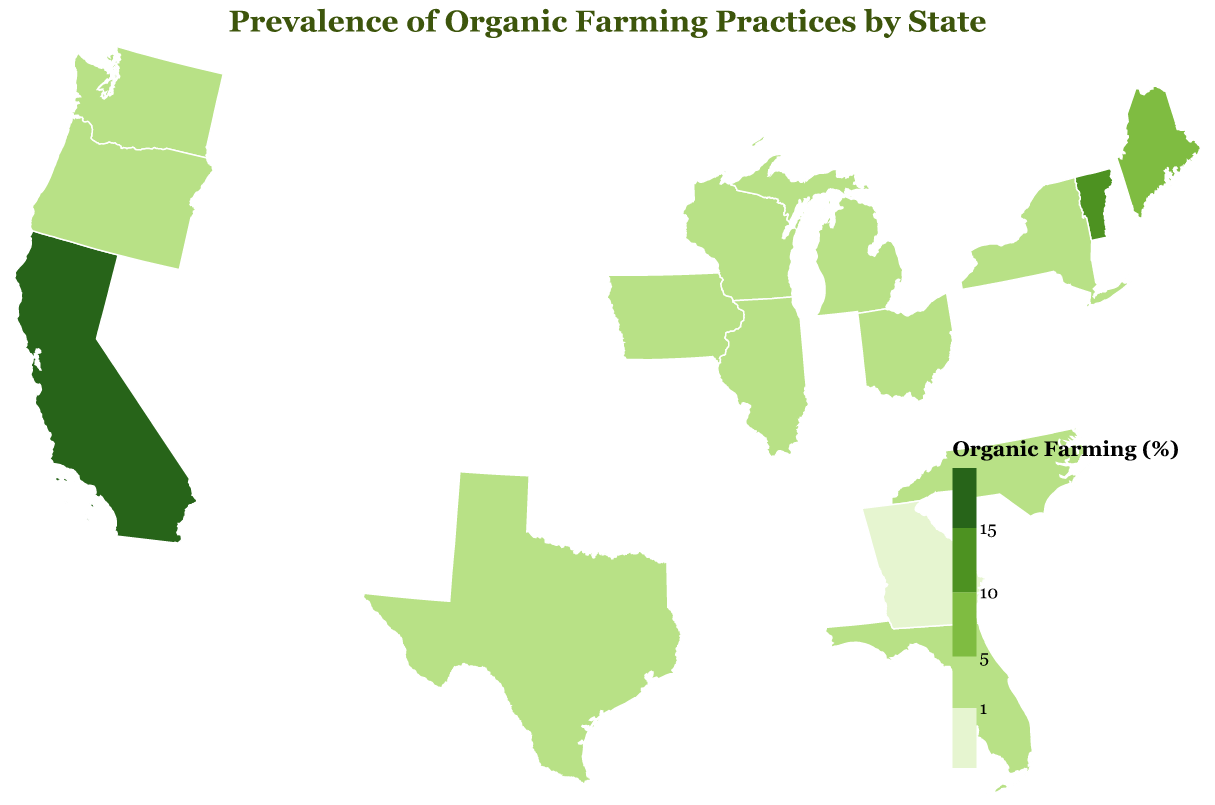What is the title of the figure? The title of a figure is usually displayed at the top and summarizes the main point of the visual data. Here, it is clearly stated at the top.
Answer: Prevalence of Organic Farming Practices by State Which state has the highest percentage of organic farming practices? By looking for the state with the highest value on the map or legend with the darkest color, you can identify the state with the highest percentage.
Answer: California What is the percentage of organic farming in Vermont? Hover over Vermont on the map or find it in the legend to see the exact percentage marked.
Answer: 14.8% Are there any states where the percentage of organic farming practices is below 1%? Looking at the color legend, which begins at 1%, then locating ways that might be lighter than the initial color level, you can determine this.
Answer: No Compare the organic farming percentages of Wisconsin and Washington. Which state has a higher percentage? Find both states on the map and compare their color shades based on the legend; the one with the darker color has a higher percentage.
Answer: Wisconsin Between Maine and New York, which state practices more organic farming, and by how much? Identify both states on the map and compare the values provided. Maine has 9.7% and New York has 4.2%. Subtract New York's percentage from Maine's to find the difference.
Answer: Maine by 5.5% Which state located in the southern United States has the highest prevalence of organic farming practices? Identify the southern states on the map, and then compare their color shades or values to determine the highest.
Answer: Texas Calculate the average percentage of organic farming practices for the states of Florida, Illinois, and Michigan. Locate the percentages for these three states (Florida: 1.7%, Illinois: 1.5%, Michigan: 1.4%), sum them up (1.7 + 1.5 + 1.4 = 4.6), and then divide by 3 to find the average.
Answer: 1.53% How does the percentage of organic farming in Oregon compare to that in Iowa? Locate both states and check their respective percentages; Oregon's is 3.4% and Iowa's is 2.8%. Compare these values directly.
Answer: Oregon is 0.6% higher What is the range of organic farming percentages shown in the figure? Find the minimum and maximum values of the organic farming percentages given for all the states. The minimum is 0.8% (Georgia) and the maximum is 20.5% (California). The range is the difference between these two values.
Answer: 19.7% 